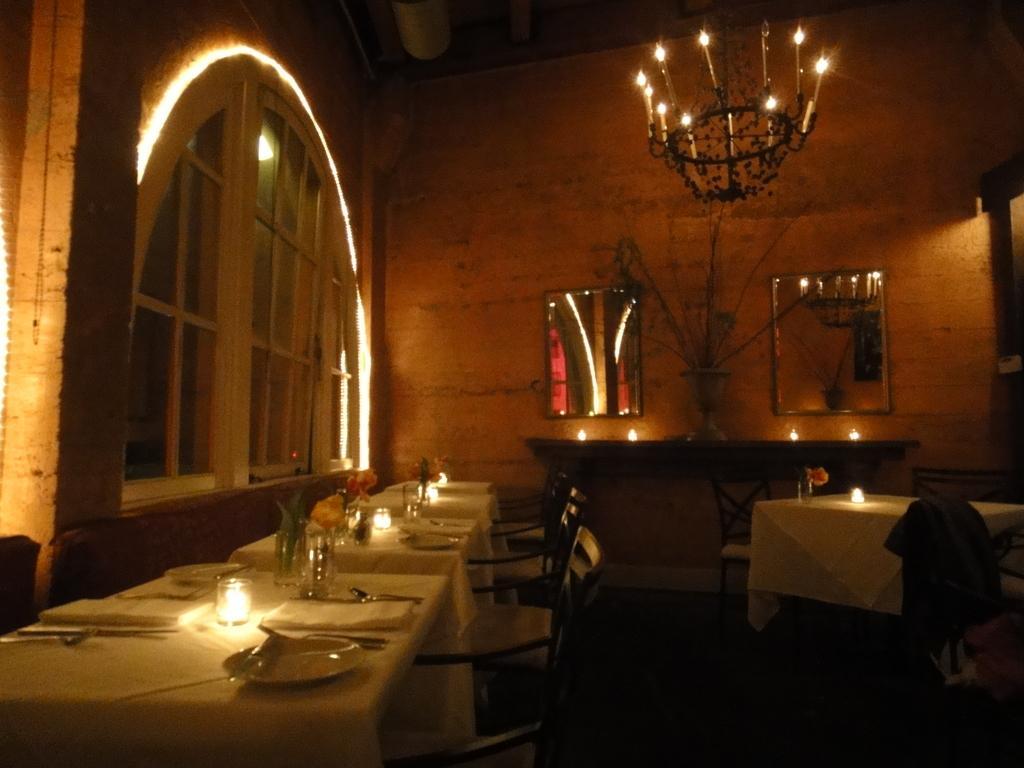Could you give a brief overview of what you see in this image? In the picture I can see tables upon which plates, forks, spoons, candles, flower vases and white table cloth are placed, where I can see chairs, candle is kept on the shelf, I can see mirrors fixed to the wall, I can see glass windows and chandeliers fixed to the ceiling in the background. 